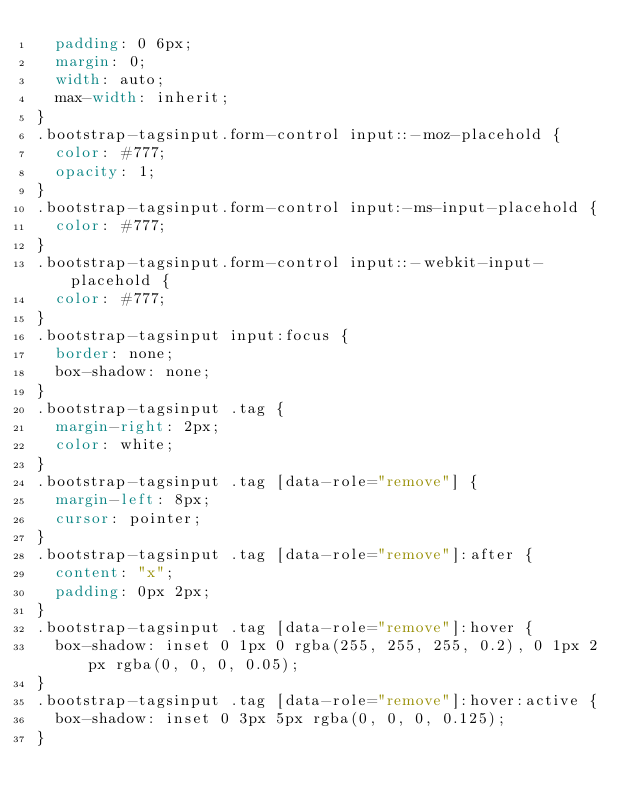Convert code to text. <code><loc_0><loc_0><loc_500><loc_500><_CSS_>  padding: 0 6px;
  margin: 0;
  width: auto;
  max-width: inherit;
}
.bootstrap-tagsinput.form-control input::-moz-placehold {
  color: #777;
  opacity: 1;
}
.bootstrap-tagsinput.form-control input:-ms-input-placehold {
  color: #777;
}
.bootstrap-tagsinput.form-control input::-webkit-input-placehold {
  color: #777;
}
.bootstrap-tagsinput input:focus {
  border: none;
  box-shadow: none;
}
.bootstrap-tagsinput .tag {
  margin-right: 2px;
  color: white;
}
.bootstrap-tagsinput .tag [data-role="remove"] {
  margin-left: 8px;
  cursor: pointer;
}
.bootstrap-tagsinput .tag [data-role="remove"]:after {
  content: "x";
  padding: 0px 2px;
}
.bootstrap-tagsinput .tag [data-role="remove"]:hover {
  box-shadow: inset 0 1px 0 rgba(255, 255, 255, 0.2), 0 1px 2px rgba(0, 0, 0, 0.05);
}
.bootstrap-tagsinput .tag [data-role="remove"]:hover:active {
  box-shadow: inset 0 3px 5px rgba(0, 0, 0, 0.125);
}
</code> 